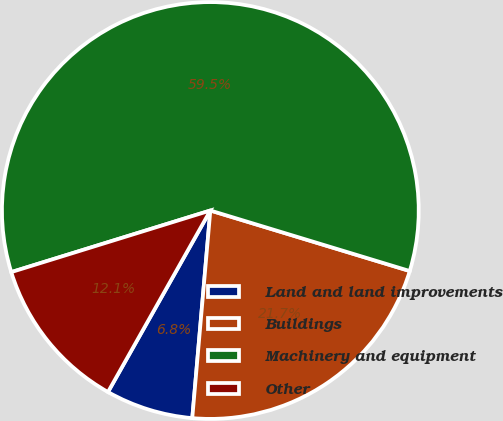<chart> <loc_0><loc_0><loc_500><loc_500><pie_chart><fcel>Land and land improvements<fcel>Buildings<fcel>Machinery and equipment<fcel>Other<nl><fcel>6.79%<fcel>21.69%<fcel>59.46%<fcel>12.05%<nl></chart> 